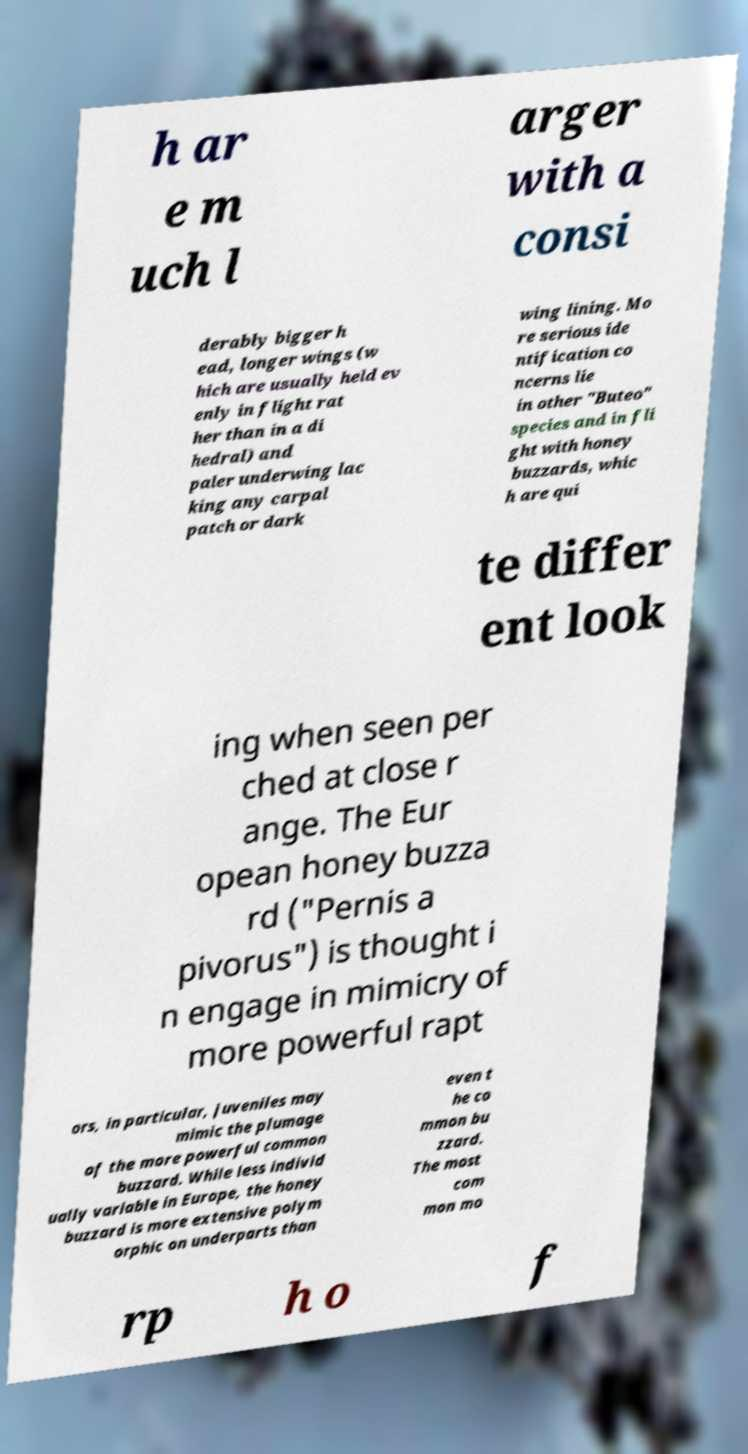There's text embedded in this image that I need extracted. Can you transcribe it verbatim? h ar e m uch l arger with a consi derably bigger h ead, longer wings (w hich are usually held ev enly in flight rat her than in a di hedral) and paler underwing lac king any carpal patch or dark wing lining. Mo re serious ide ntification co ncerns lie in other "Buteo" species and in fli ght with honey buzzards, whic h are qui te differ ent look ing when seen per ched at close r ange. The Eur opean honey buzza rd ("Pernis a pivorus") is thought i n engage in mimicry of more powerful rapt ors, in particular, juveniles may mimic the plumage of the more powerful common buzzard. While less individ ually variable in Europe, the honey buzzard is more extensive polym orphic on underparts than even t he co mmon bu zzard. The most com mon mo rp h o f 